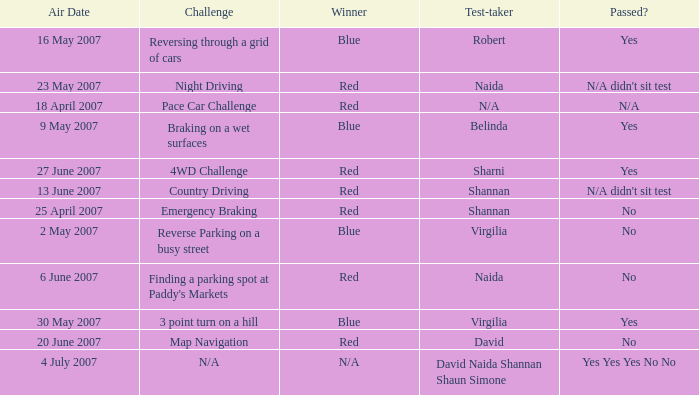What air date has a red winner and an emergency braking challenge? 25 April 2007. 